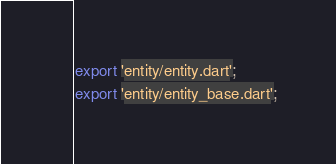<code> <loc_0><loc_0><loc_500><loc_500><_Dart_>export 'entity/entity.dart';
export 'entity/entity_base.dart';
</code> 